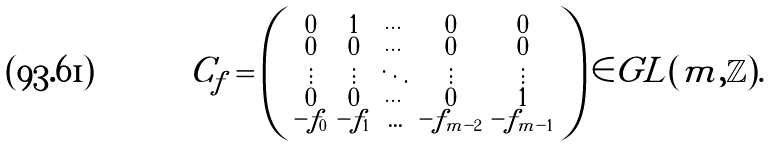Convert formula to latex. <formula><loc_0><loc_0><loc_500><loc_500>C _ { f } = \left ( \begin{smallmatrix} 0 & 1 & \cdots & 0 & 0 \\ 0 & 0 & \cdots & 0 & 0 \\ \vdots & \vdots & \ddots & \vdots & \vdots \\ 0 & 0 & \cdots & 0 & 1 \\ - f _ { 0 } & - f _ { 1 } & \hdots & - f _ { m - 2 } & - f _ { m - 1 } \end{smallmatrix} \right ) \in G L ( m , \mathbb { Z } ) .</formula> 